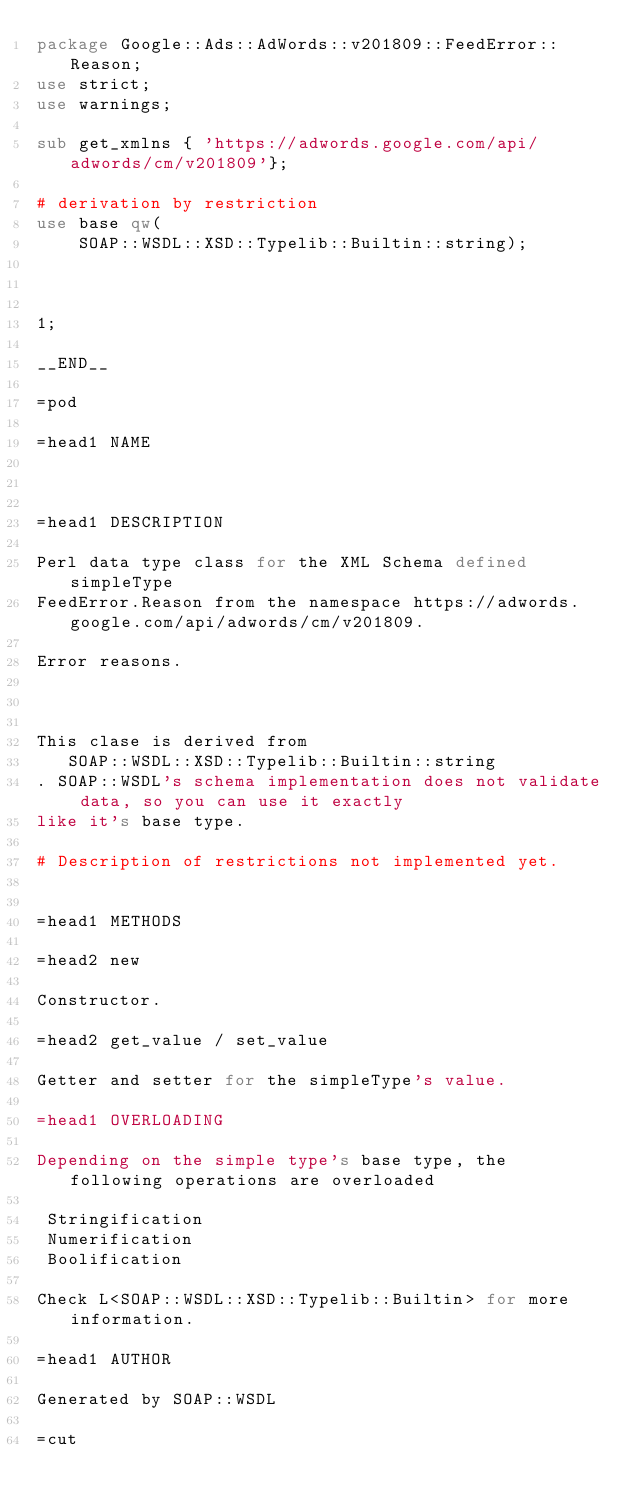<code> <loc_0><loc_0><loc_500><loc_500><_Perl_>package Google::Ads::AdWords::v201809::FeedError::Reason;
use strict;
use warnings;

sub get_xmlns { 'https://adwords.google.com/api/adwords/cm/v201809'};

# derivation by restriction
use base qw(
    SOAP::WSDL::XSD::Typelib::Builtin::string);



1;

__END__

=pod

=head1 NAME



=head1 DESCRIPTION

Perl data type class for the XML Schema defined simpleType
FeedError.Reason from the namespace https://adwords.google.com/api/adwords/cm/v201809.

Error reasons. 



This clase is derived from 
   SOAP::WSDL::XSD::Typelib::Builtin::string
. SOAP::WSDL's schema implementation does not validate data, so you can use it exactly
like it's base type.

# Description of restrictions not implemented yet.


=head1 METHODS

=head2 new

Constructor.

=head2 get_value / set_value

Getter and setter for the simpleType's value.

=head1 OVERLOADING

Depending on the simple type's base type, the following operations are overloaded

 Stringification
 Numerification
 Boolification

Check L<SOAP::WSDL::XSD::Typelib::Builtin> for more information.

=head1 AUTHOR

Generated by SOAP::WSDL

=cut

</code> 